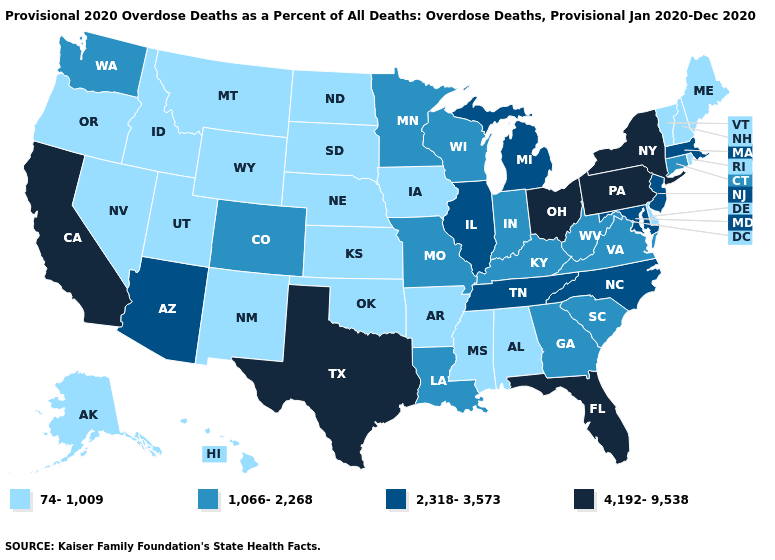What is the lowest value in the South?
Keep it brief. 74-1,009. What is the value of Maine?
Short answer required. 74-1,009. What is the value of Colorado?
Keep it brief. 1,066-2,268. Name the states that have a value in the range 74-1,009?
Keep it brief. Alabama, Alaska, Arkansas, Delaware, Hawaii, Idaho, Iowa, Kansas, Maine, Mississippi, Montana, Nebraska, Nevada, New Hampshire, New Mexico, North Dakota, Oklahoma, Oregon, Rhode Island, South Dakota, Utah, Vermont, Wyoming. Which states have the highest value in the USA?
Short answer required. California, Florida, New York, Ohio, Pennsylvania, Texas. What is the value of Kentucky?
Answer briefly. 1,066-2,268. What is the value of Arizona?
Give a very brief answer. 2,318-3,573. Does the first symbol in the legend represent the smallest category?
Answer briefly. Yes. Which states have the lowest value in the Northeast?
Be succinct. Maine, New Hampshire, Rhode Island, Vermont. What is the lowest value in states that border North Dakota?
Concise answer only. 74-1,009. Does California have the same value as Florida?
Keep it brief. Yes. Does Montana have the lowest value in the West?
Give a very brief answer. Yes. What is the value of Mississippi?
Give a very brief answer. 74-1,009. Does New York have the lowest value in the Northeast?
Short answer required. No. Does Virginia have the highest value in the USA?
Be succinct. No. 